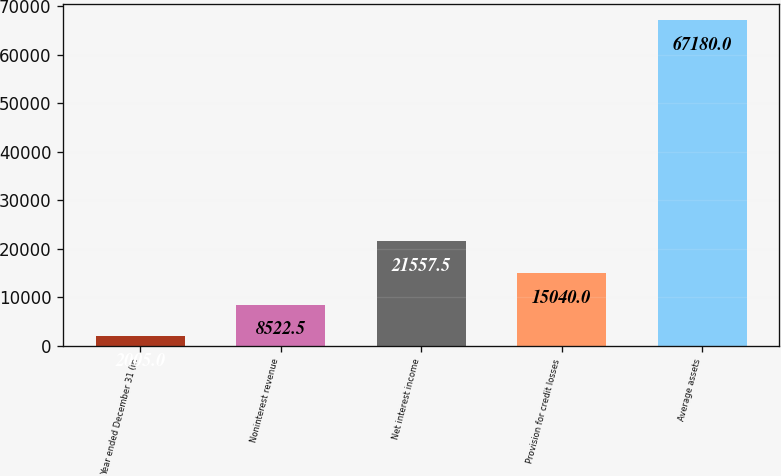Convert chart. <chart><loc_0><loc_0><loc_500><loc_500><bar_chart><fcel>Year ended December 31 (in<fcel>Noninterest revenue<fcel>Net interest income<fcel>Provision for credit losses<fcel>Average assets<nl><fcel>2005<fcel>8522.5<fcel>21557.5<fcel>15040<fcel>67180<nl></chart> 